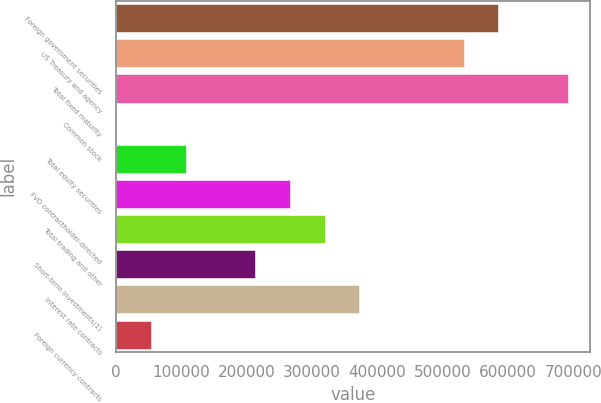Convert chart to OTSL. <chart><loc_0><loc_0><loc_500><loc_500><bar_chart><fcel>Foreign government securities<fcel>US Treasury and agency<fcel>Total fixed maturity<fcel>Common stock<fcel>Total equity securities<fcel>FVO contractholder-directed<fcel>Total trading and other<fcel>Short-term investments(1)<fcel>Interest rate contracts<fcel>Foreign currency contracts<nl><fcel>585341<fcel>532229<fcel>691566<fcel>1105<fcel>107330<fcel>266667<fcel>319779<fcel>213555<fcel>372892<fcel>54217.4<nl></chart> 